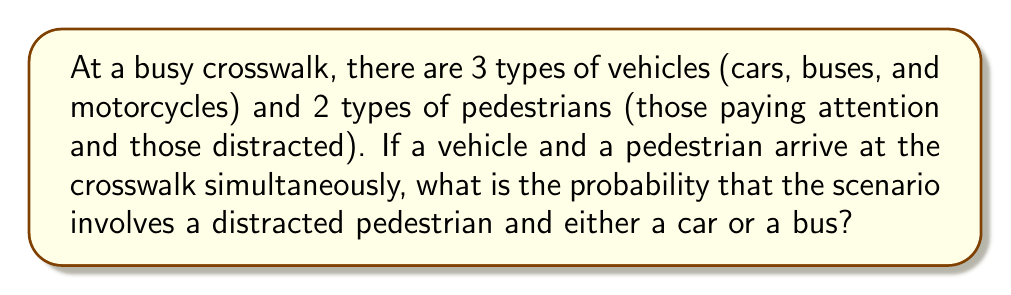What is the answer to this math problem? Let's approach this step-by-step:

1) First, we need to determine the total number of possible scenarios. We have:
   - 3 types of vehicles
   - 2 types of pedestrians
   So, the total number of scenarios is: $3 \times 2 = 6$

2) Now, let's identify the favorable scenarios:
   - Distracted pedestrian and car
   - Distracted pedestrian and bus

3) To calculate the probability, we use the formula:

   $$P(\text{event}) = \frac{\text{number of favorable outcomes}}{\text{total number of possible outcomes}}$$

4) In this case:
   - Number of favorable outcomes = 2 (distracted pedestrian with car or bus)
   - Total number of possible outcomes = 6

5) Therefore, the probability is:

   $$P(\text{distracted pedestrian and (car or bus)}) = \frac{2}{6} = \frac{1}{3}$$
Answer: $\frac{1}{3}$ 